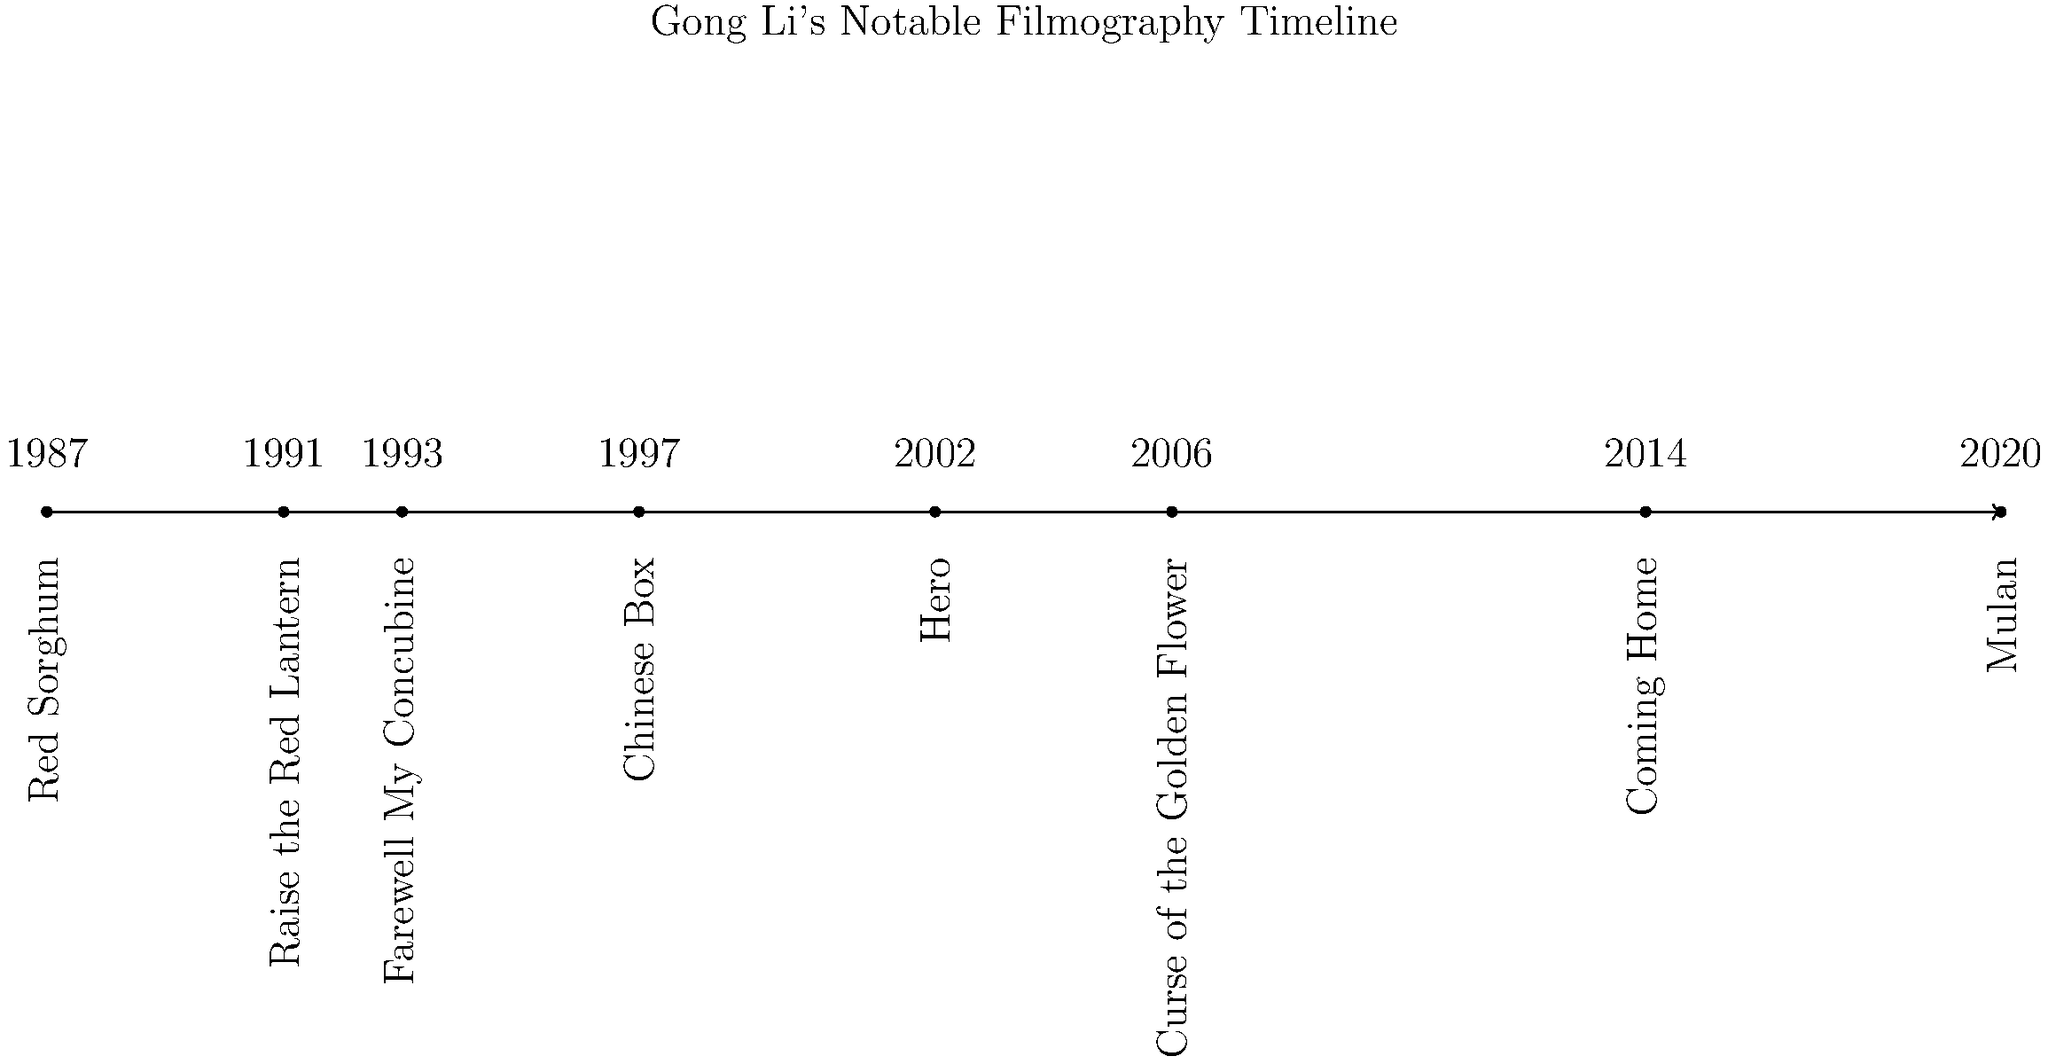Based on the timeline of Gong Li's filmography, which movie marked her collaboration with Zhang Yimou after a significant gap, showcasing her return to Chinese cinema? To answer this question, let's analyze Gong Li's filmography timeline:

1. We can see that Gong Li's career began with "Red Sorghum" in 1987, directed by Zhang Yimou.
2. She continued to work with Zhang Yimou on "Raise the Red Lantern" in 1991.
3. In 1993, she starred in "Farewell My Concubine", directed by Chen Kaige.
4. "Chinese Box" in 1997 was an international production.
5. In 2002, she appeared in Zhang Yimou's "Hero".
6. "Curse of the Golden Flower" in 2006 was another collaboration with Zhang Yimou.
7. There's a significant gap in her major Chinese film appearances between 2006 and 2014.
8. In 2014, "Coming Home" marked her return to Chinese cinema and her reunion with Zhang Yimou after a long break.
9. Her most recent notable appearance is in the international production "Mulan" in 2020.

Given this analysis, "Coming Home" in 2014 represents Gong Li's return to Chinese cinema and her collaboration with Zhang Yimou after a significant gap.
Answer: Coming Home (2014) 